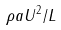Convert formula to latex. <formula><loc_0><loc_0><loc_500><loc_500>\rho a U ^ { 2 } / L</formula> 